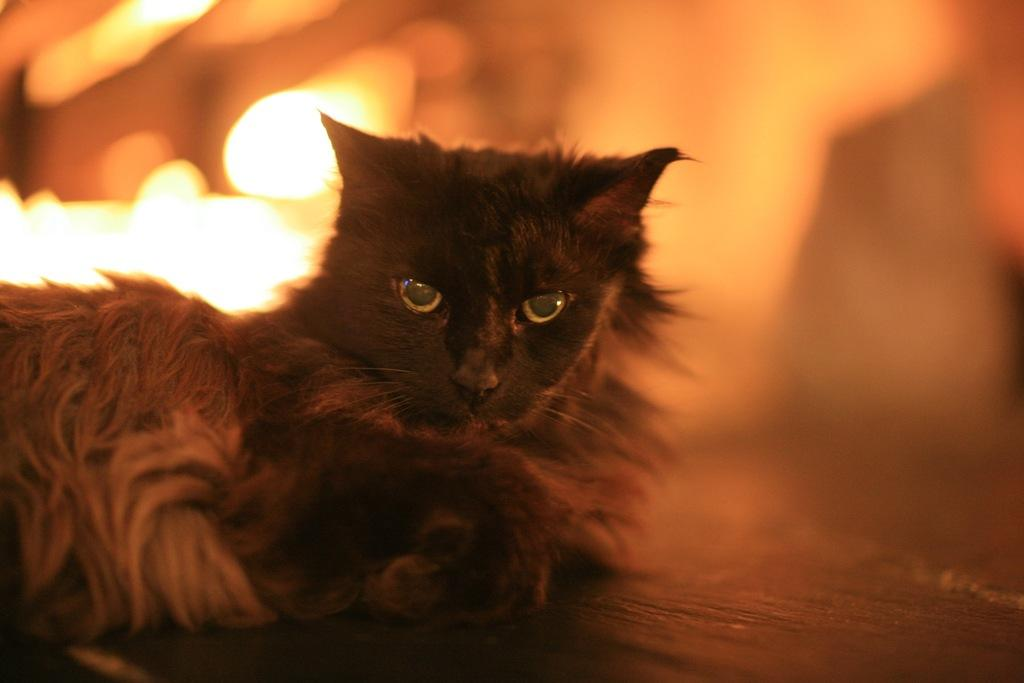What animal is located on the left side of the image? There is a cat on the left side of the image. What surface is visible at the bottom of the image? There is a floor at the bottom of the image. Can you describe the background of the image? The background of the image is blurry. In which direction is the knife pointing in the image? There is no knife present in the image. 